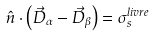Convert formula to latex. <formula><loc_0><loc_0><loc_500><loc_500>\hat { n } \cdot \left ( \vec { D } _ { \alpha } - \vec { D } _ { \beta } \right ) = \sigma _ { s } ^ { l i v r e }</formula> 